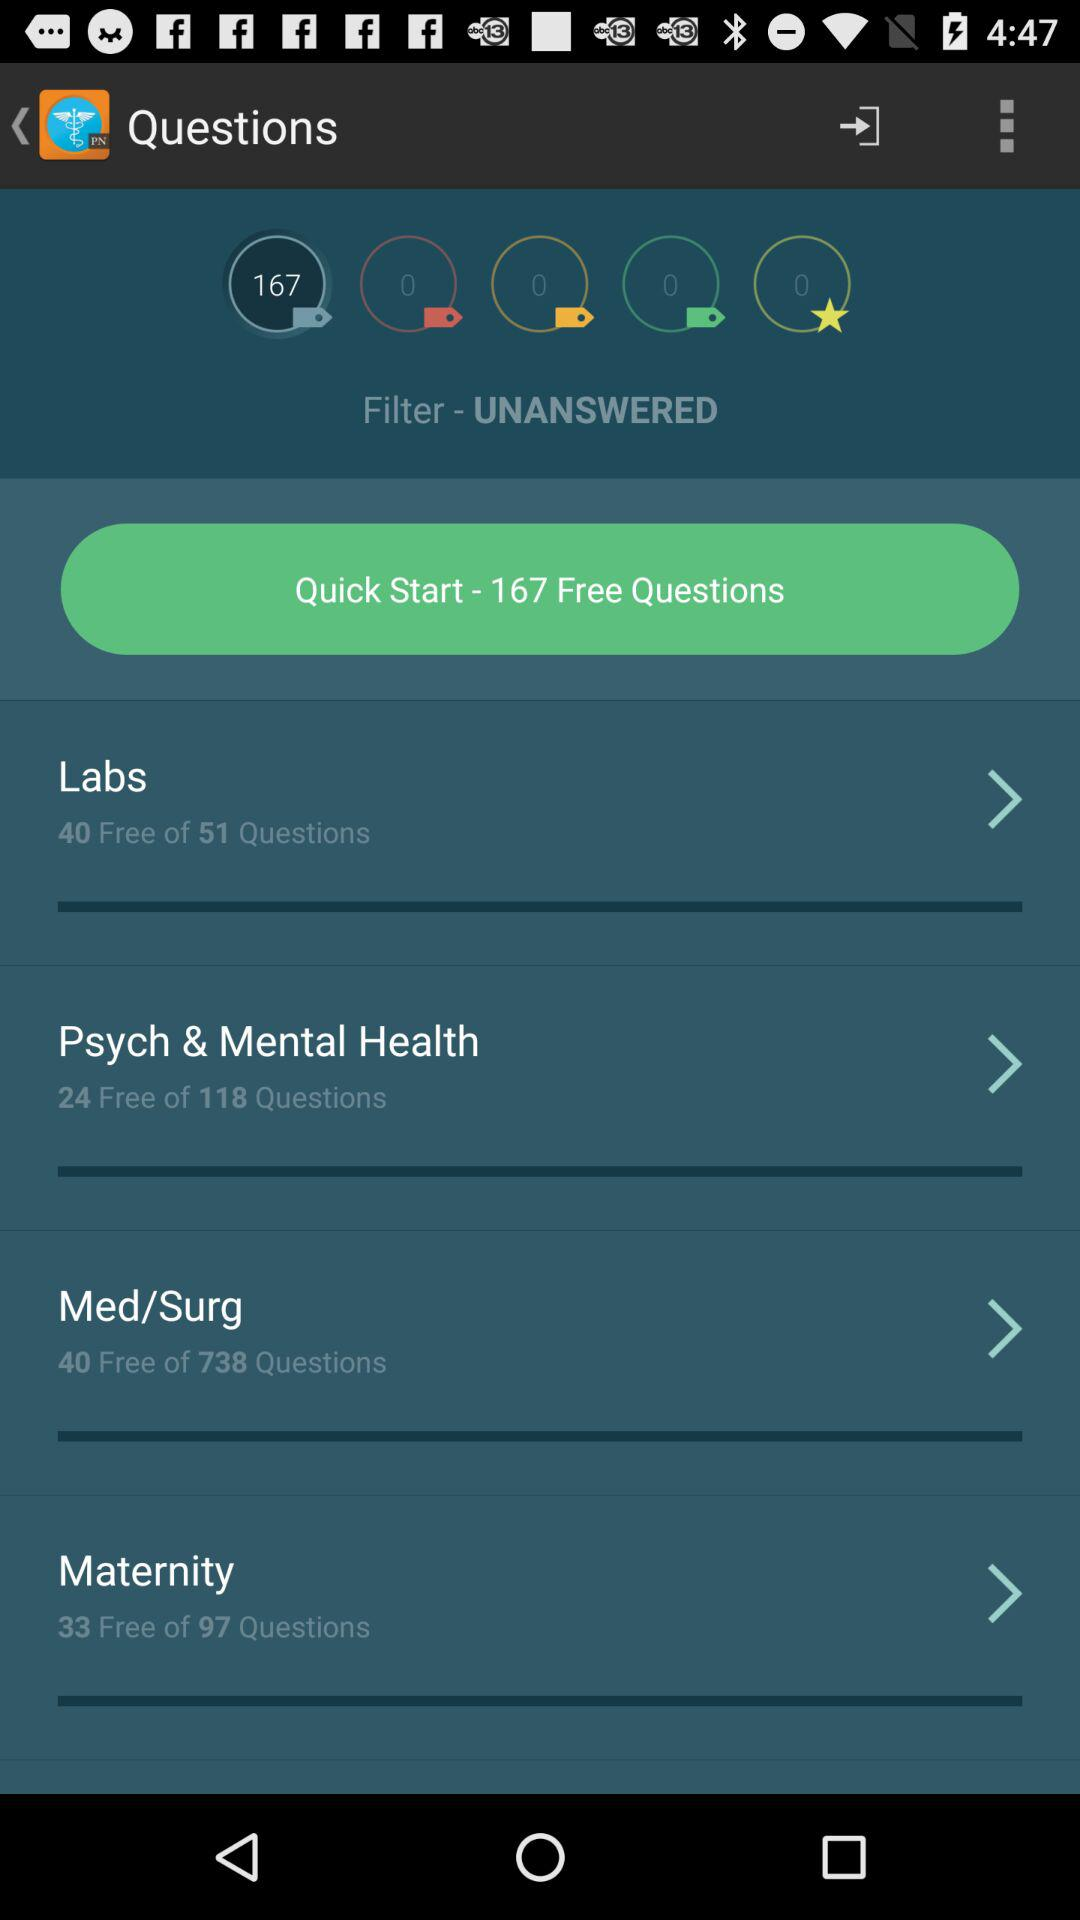What are the total free questions available in all the courses? There are 167 free questions. 